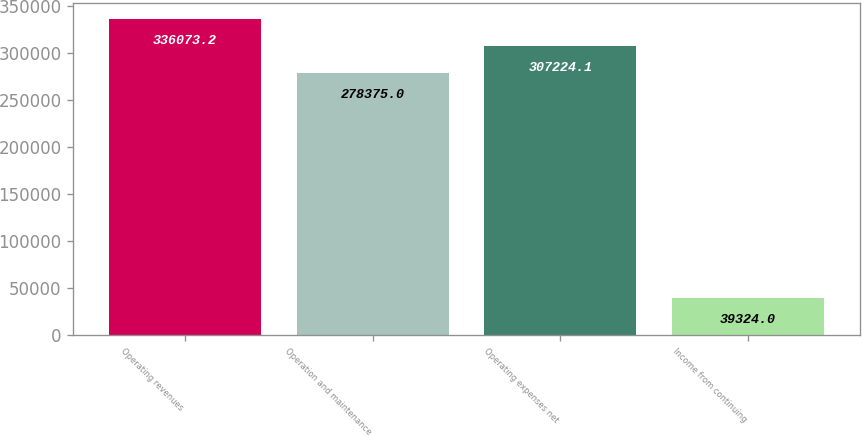Convert chart to OTSL. <chart><loc_0><loc_0><loc_500><loc_500><bar_chart><fcel>Operating revenues<fcel>Operation and maintenance<fcel>Operating expenses net<fcel>Income from continuing<nl><fcel>336073<fcel>278375<fcel>307224<fcel>39324<nl></chart> 